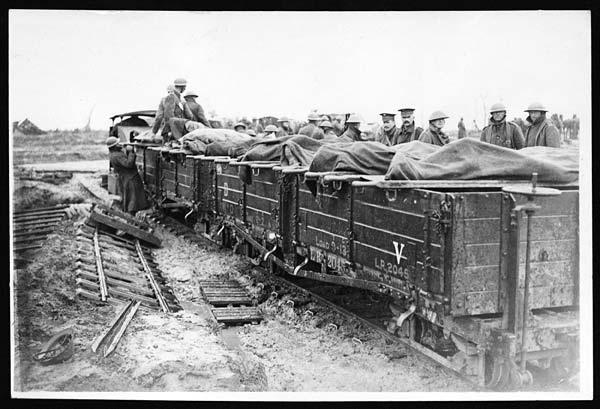Was this photo taken during a war?
Be succinct. Yes. Is the train in the mountains?
Concise answer only. No. Are the people traveling?
Concise answer only. Yes. How many umbrellas are there?
Write a very short answer. 0. What letter on the train is closest to the viewer?
Concise answer only. V. What is the race of the man on the train?
Concise answer only. White. 